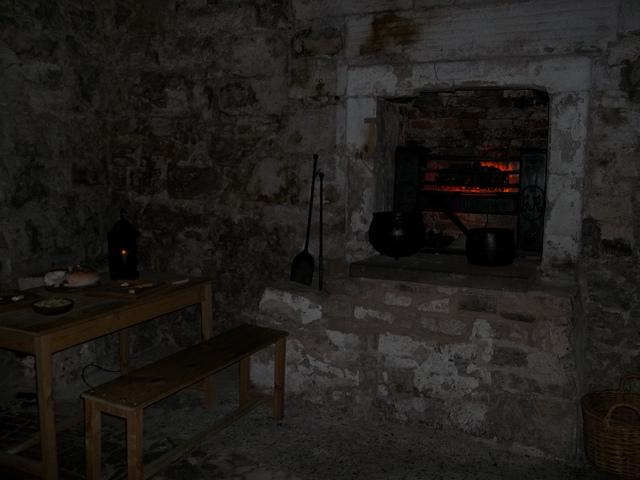What type of heat is shown?

Choices:
A) radiator
B) blanket
C) fire
D) coat fire 